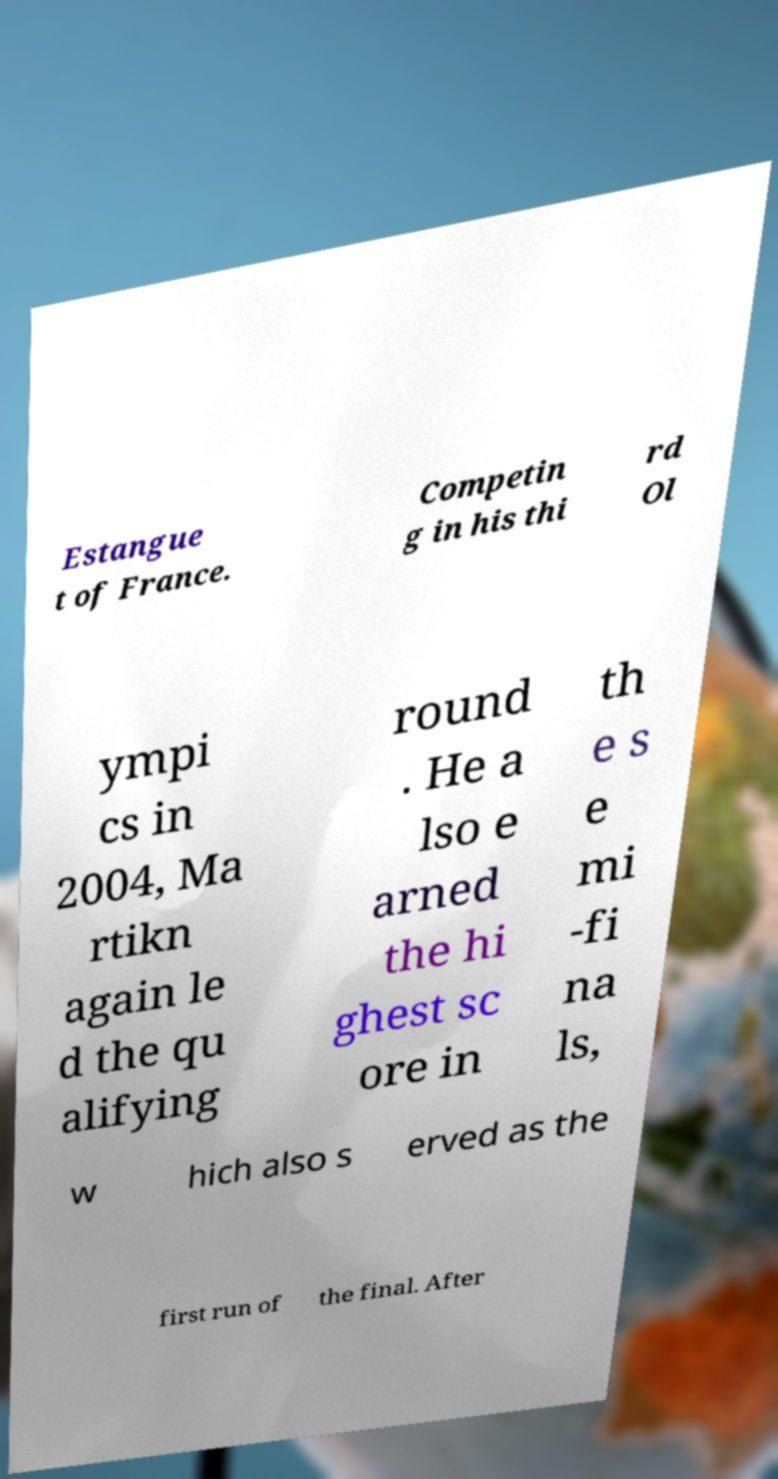Please identify and transcribe the text found in this image. Estangue t of France. Competin g in his thi rd Ol ympi cs in 2004, Ma rtikn again le d the qu alifying round . He a lso e arned the hi ghest sc ore in th e s e mi -fi na ls, w hich also s erved as the first run of the final. After 